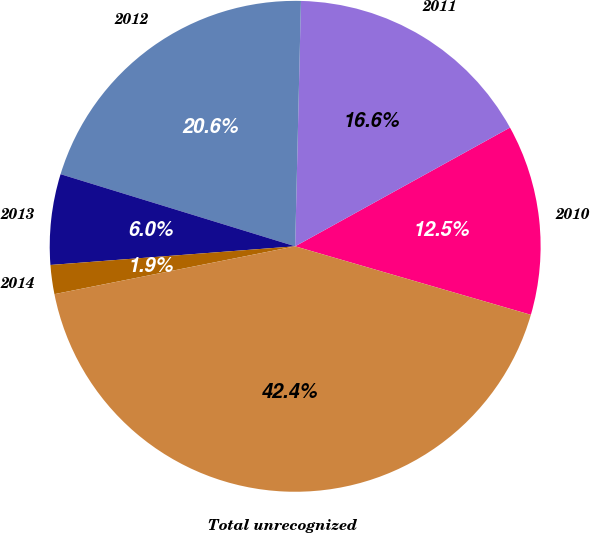<chart> <loc_0><loc_0><loc_500><loc_500><pie_chart><fcel>2010<fcel>2011<fcel>2012<fcel>2013<fcel>2014<fcel>Total unrecognized<nl><fcel>12.54%<fcel>16.59%<fcel>20.63%<fcel>5.96%<fcel>1.91%<fcel>42.38%<nl></chart> 